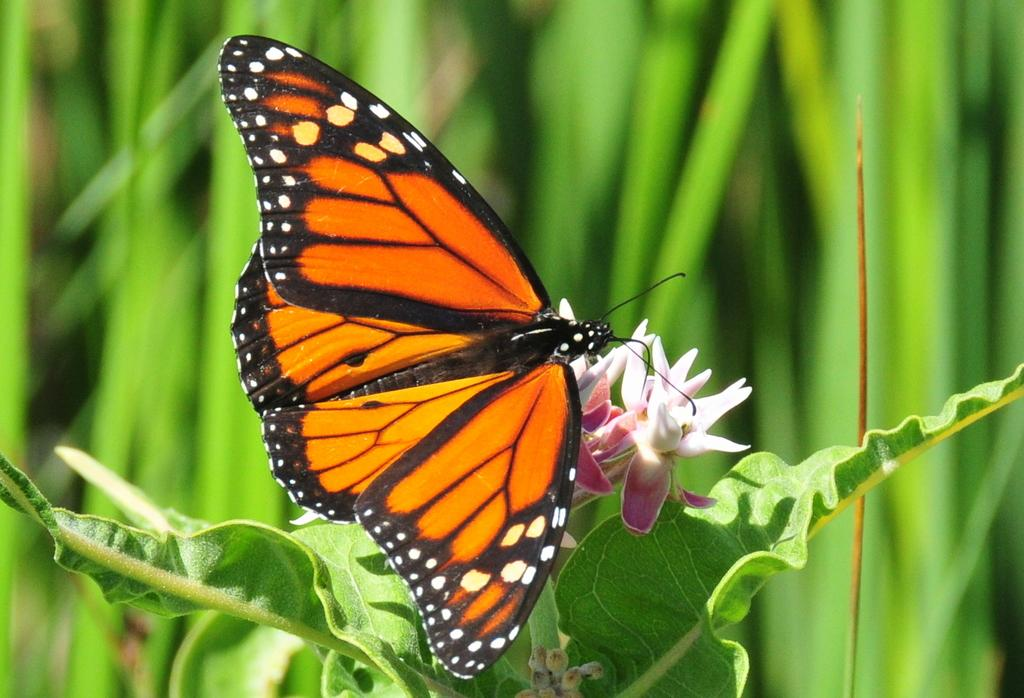What is the color of the background in the image? The background of the image is green and blurred. What type of vegetation can be seen in the image? There are green leaves in the image. What animal is present in the image? There is a butterfly in the image. What other flora can be seen in the image? There are flowers and buds in the image. How does the kitty express its anger in the image? There is no kitty present in the image, so it cannot express any emotions. 